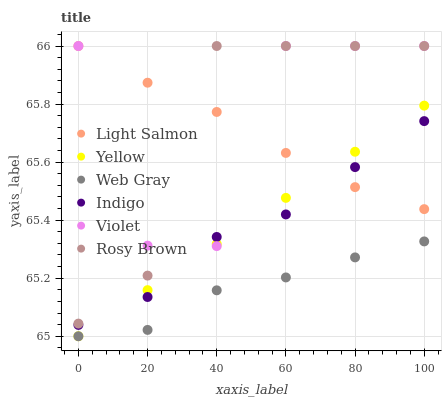Does Web Gray have the minimum area under the curve?
Answer yes or no. Yes. Does Rosy Brown have the maximum area under the curve?
Answer yes or no. Yes. Does Indigo have the minimum area under the curve?
Answer yes or no. No. Does Indigo have the maximum area under the curve?
Answer yes or no. No. Is Yellow the smoothest?
Answer yes or no. Yes. Is Violet the roughest?
Answer yes or no. Yes. Is Web Gray the smoothest?
Answer yes or no. No. Is Web Gray the roughest?
Answer yes or no. No. Does Web Gray have the lowest value?
Answer yes or no. Yes. Does Indigo have the lowest value?
Answer yes or no. No. Does Violet have the highest value?
Answer yes or no. Yes. Does Indigo have the highest value?
Answer yes or no. No. Is Web Gray less than Indigo?
Answer yes or no. Yes. Is Violet greater than Web Gray?
Answer yes or no. Yes. Does Indigo intersect Violet?
Answer yes or no. Yes. Is Indigo less than Violet?
Answer yes or no. No. Is Indigo greater than Violet?
Answer yes or no. No. Does Web Gray intersect Indigo?
Answer yes or no. No. 